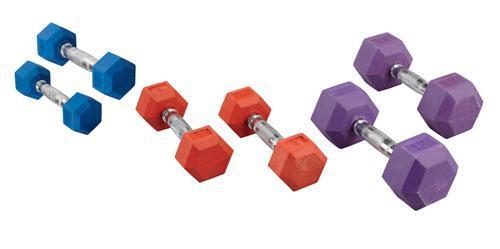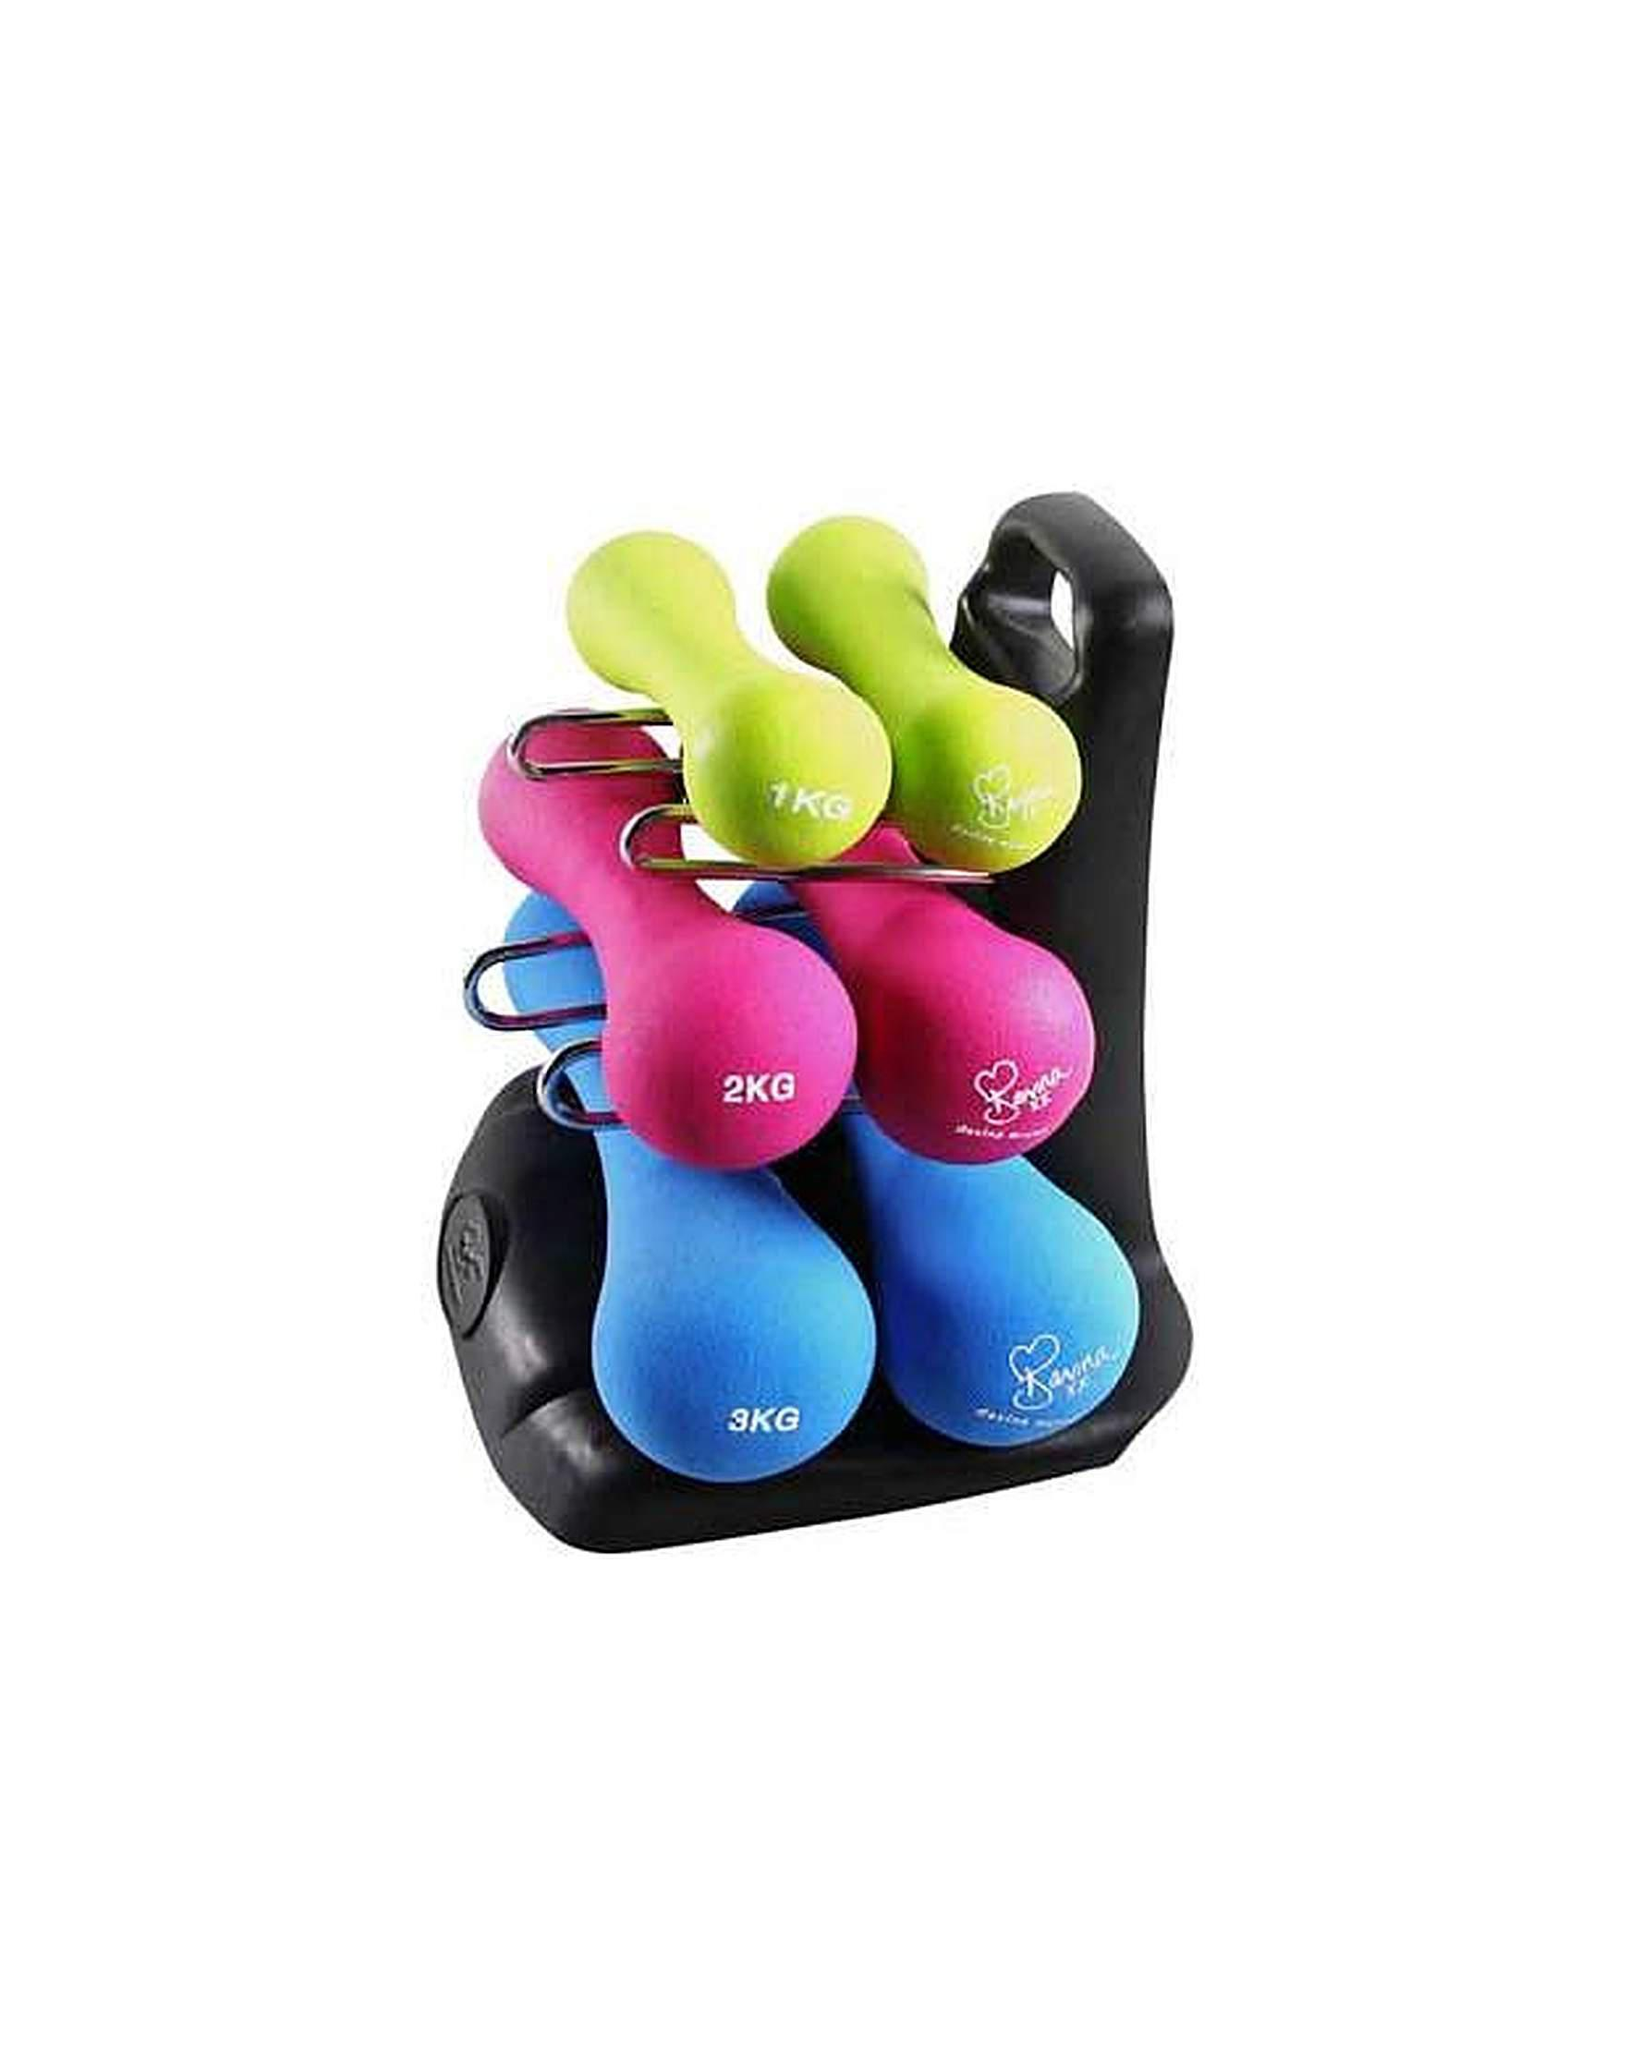The first image is the image on the left, the second image is the image on the right. Examine the images to the left and right. Is the description "An image shows a neat row of dumbbells arranged by weight that includes at least four different colored ends." accurate? Answer yes or no. No. 